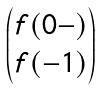<formula> <loc_0><loc_0><loc_500><loc_500>\begin{pmatrix} f ( 0 - ) \\ f ( - 1 ) \end{pmatrix}</formula> 